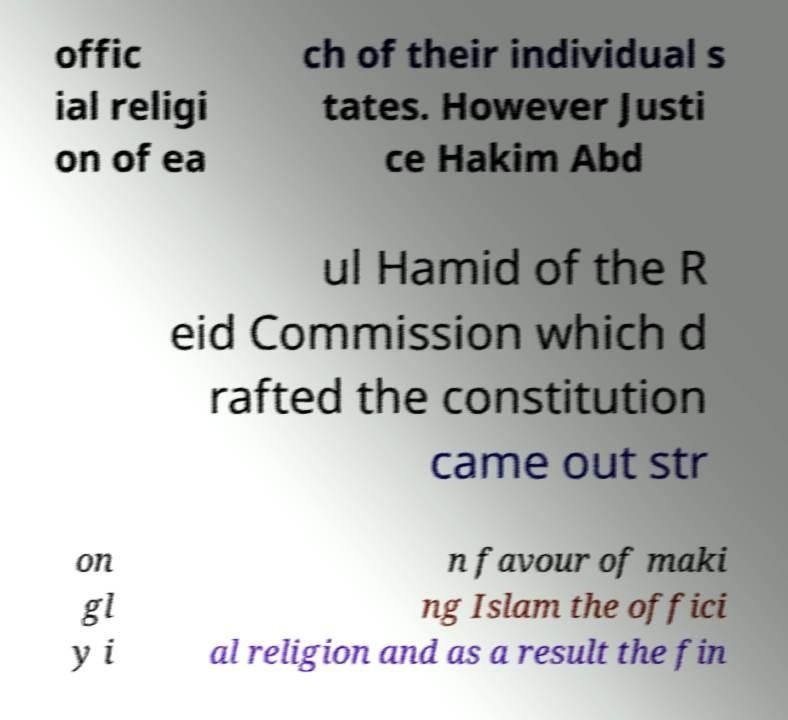Can you read and provide the text displayed in the image?This photo seems to have some interesting text. Can you extract and type it out for me? offic ial religi on of ea ch of their individual s tates. However Justi ce Hakim Abd ul Hamid of the R eid Commission which d rafted the constitution came out str on gl y i n favour of maki ng Islam the offici al religion and as a result the fin 